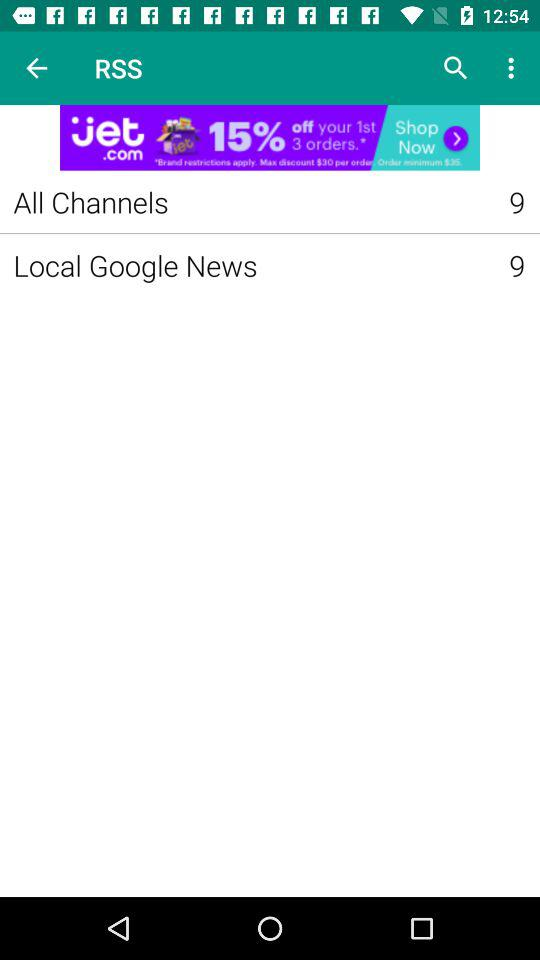How many "All Channels" are there in RSS? There are 9 "All Channels" in RSS. 